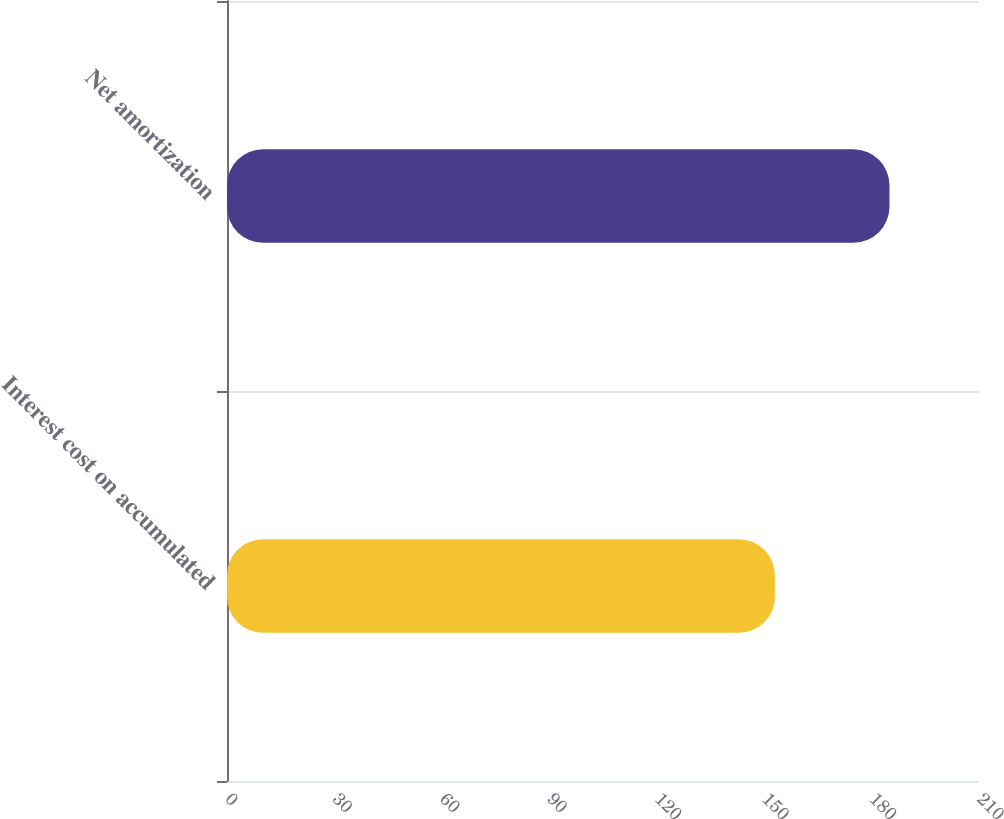Convert chart to OTSL. <chart><loc_0><loc_0><loc_500><loc_500><bar_chart><fcel>Interest cost on accumulated<fcel>Net amortization<nl><fcel>153<fcel>185<nl></chart> 